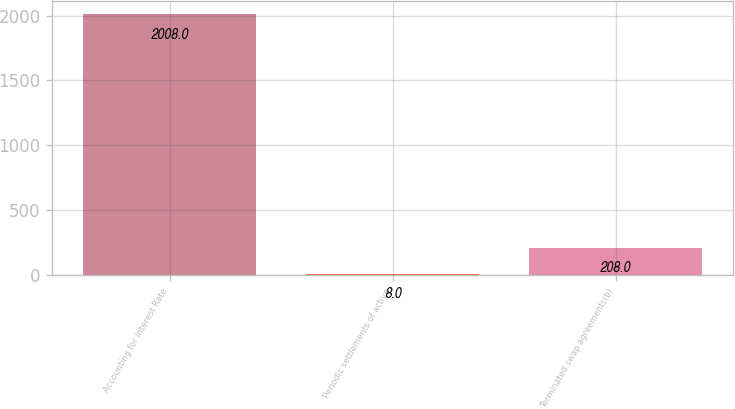Convert chart. <chart><loc_0><loc_0><loc_500><loc_500><bar_chart><fcel>Accounting for Interest Rate<fcel>Periodic settlements of active<fcel>Terminated swap agreements(b)<nl><fcel>2008<fcel>8<fcel>208<nl></chart> 